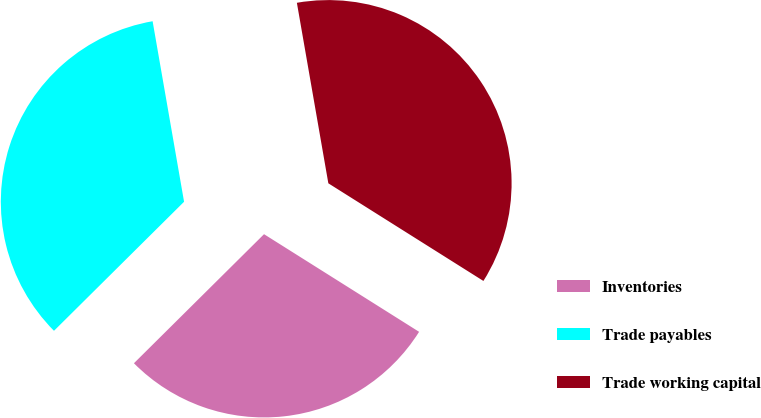<chart> <loc_0><loc_0><loc_500><loc_500><pie_chart><fcel>Inventories<fcel>Trade payables<fcel>Trade working capital<nl><fcel>28.62%<fcel>34.69%<fcel>36.69%<nl></chart> 